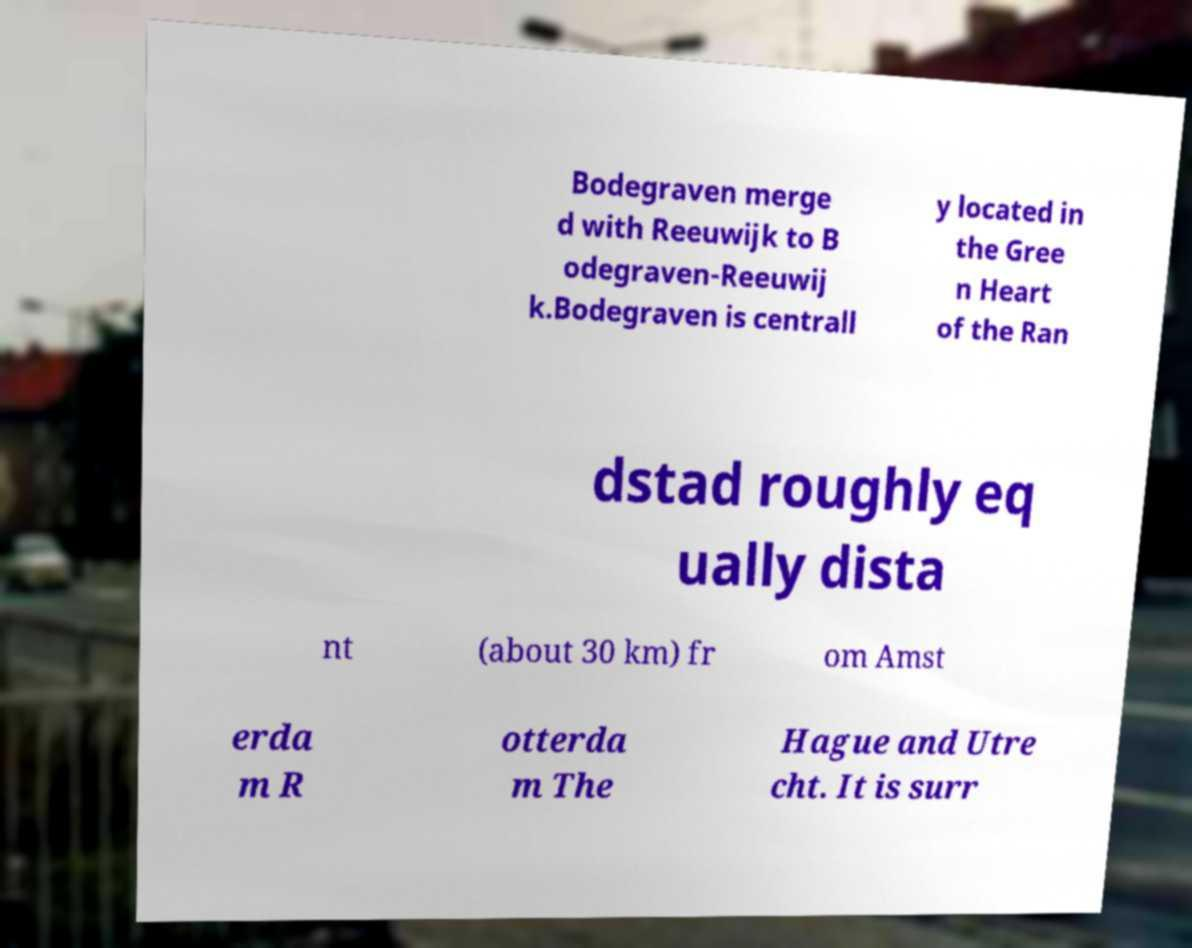There's text embedded in this image that I need extracted. Can you transcribe it verbatim? Bodegraven merge d with Reeuwijk to B odegraven-Reeuwij k.Bodegraven is centrall y located in the Gree n Heart of the Ran dstad roughly eq ually dista nt (about 30 km) fr om Amst erda m R otterda m The Hague and Utre cht. It is surr 